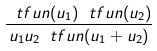Convert formula to latex. <formula><loc_0><loc_0><loc_500><loc_500>\frac { \ t f u n ( u _ { 1 } ) \ t f u n ( u _ { 2 } ) } { u _ { 1 } u _ { 2 } \ t f u n ( u _ { 1 } + u _ { 2 } ) }</formula> 